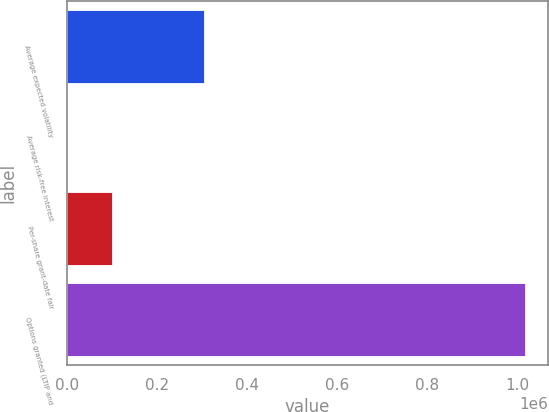<chart> <loc_0><loc_0><loc_500><loc_500><bar_chart><fcel>Average expected volatility<fcel>Average risk-free interest<fcel>Per-share grant-date fair<fcel>Options granted (LTIP and<nl><fcel>305011<fcel>1.88<fcel>101672<fcel>1.0167e+06<nl></chart> 